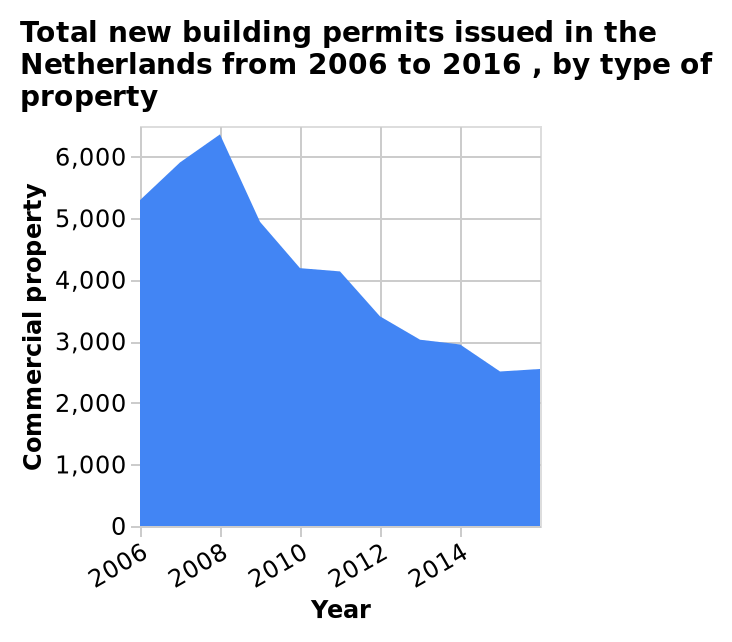<image>
What is the measurement scale for commercial property on the y-axis? The measurement scale for commercial property on the y-axis is linear, ranging from 0 to 6,000. What does the x-axis represent? The x-axis represents the years from 2006 to 2016. What types of buildings were affected by the decrease in permission to build in 2008? The decrease in permission to build affected new houses, factories, and public buildings. 